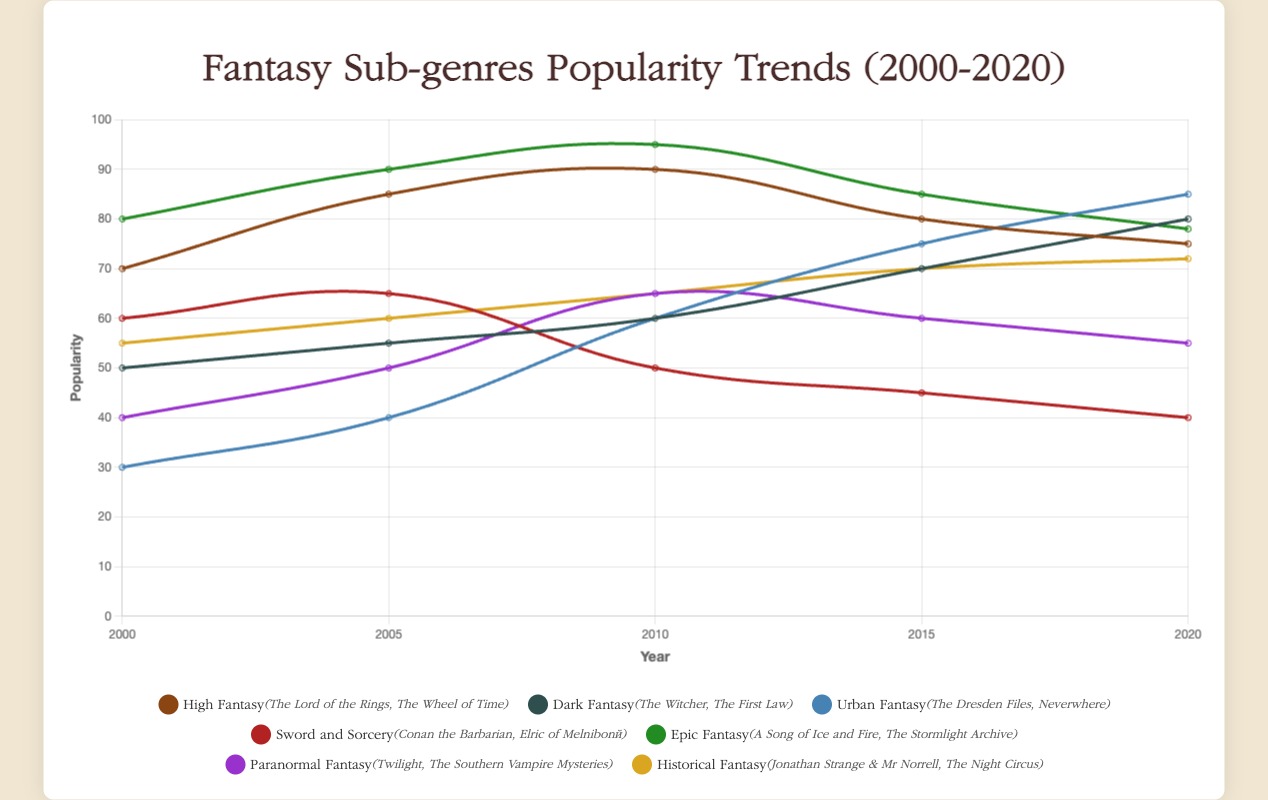What sub-genre had the highest popularity in 2010? Observing the lines in the plot, Epic Fantasy is at 95 in 2010, which is higher than any other sub-genre for that year.
Answer: Epic Fantasy Which sub-genre's popularity declined the most between 2000 and 2020? Comparing the start and end points, Sword and Sorcery declined from 60 to 40, which is a decrease of 20. This is the largest decrement among all sub-genres.
Answer: Sword and Sorcery Among High Fantasy, Dark Fantasy, and Urban Fantasy, which sub-genre showed the highest popularity in 2015? Looking at the plot for 2015, High Fantasy is at 80, Dark Fantasy is at 70, and Urban Fantasy is at 75. Therefore, High Fantasy has the highest popularity among the three.
Answer: High Fantasy What is the combined popularity of Paranormal Fantasy and Historical Fantasy in 2020? In 2020, Paranormal Fantasy is at 55, and Historical Fantasy is at 72. Combined, they have a popularity of 55 + 72 = 127.
Answer: 127 Which sub-genre experienced continuous growth over the entire period from 2000 to 2020? Observing the trend lines, Dark Fantasy starts at 50 in 2000 and continuously increases to 80 in 2020, without any declines.
Answer: Dark Fantasy Of the sub-genres that had a popularity higher than 70 in 2005, which one saw the smallest increase by 2020? In 2005, the sub-genres with popularity higher than 70 are High Fantasy (85), Epic Fantasy (90), and Sword and Sorcery (65). By 2020, Epic Fantasy increases by -12 (78 - 90), High Fantasy by -10 (75 - 85), Sword and Sorcery by -25 (40 - 65).
Answer: Epic Fantasy What was the average popularity of High Fantasy over the years? The values for High Fantasy from 2000 to 2020 are 70, 85, 90, 80, 75. The sum is 70 + 85 + 90 + 80 + 75 = 400. There are 5 data points, so the average is 400 / 5 = 80.
Answer: 80 Compared to Urban Fantasy, how much did Dark Fantasy's popularity change between 2005 and 2015? Dark Fantasy changes from 55 to 70, an increase of 15. Urban Fantasy changes from 40 to 75, an increase of 35. The difference in change is 35 - 15 = 20.
Answer: 20 Which sub-genre overtook another in popularity from 2010 to 2020? Between 2010 and 2020, Urban Fantasy overtook High Fantasy, starting at 60 in 2010 and surpassing High Fantasy which declined from 90 to 75 by 2020.
Answer: Urban Fantasy over High Fantasy What is the only sub-genre that remained under 70 in popularity throughout the entire time period? Observing all the lines, Paranormal Fantasy remained under 70 from 2000 to 2020, with values of 40, 50, 65, 60, and 55.
Answer: Paranormal Fantasy 